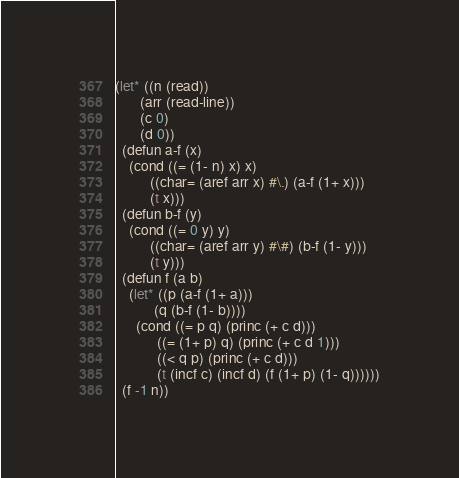<code> <loc_0><loc_0><loc_500><loc_500><_Lisp_>(let* ((n (read))
       (arr (read-line))
       (c 0)
       (d 0))
  (defun a-f (x)
    (cond ((= (1- n) x) x)
          ((char= (aref arr x) #\.) (a-f (1+ x)))
          (t x)))
  (defun b-f (y)
    (cond ((= 0 y) y)
          ((char= (aref arr y) #\#) (b-f (1- y)))
          (t y)))
  (defun f (a b)
    (let* ((p (a-f (1+ a)))
           (q (b-f (1- b))))
      (cond ((= p q) (princ (+ c d)))
            ((= (1+ p) q) (princ (+ c d 1)))
            ((< q p) (princ (+ c d)))
            (t (incf c) (incf d) (f (1+ p) (1- q))))))
  (f -1 n))</code> 